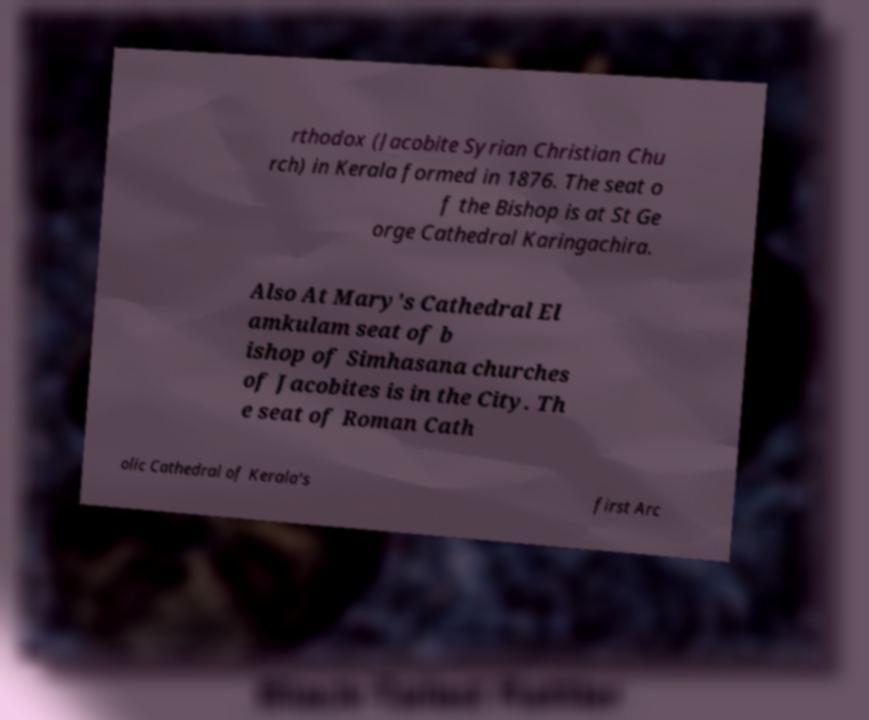What messages or text are displayed in this image? I need them in a readable, typed format. rthodox (Jacobite Syrian Christian Chu rch) in Kerala formed in 1876. The seat o f the Bishop is at St Ge orge Cathedral Karingachira. Also At Mary's Cathedral El amkulam seat of b ishop of Simhasana churches of Jacobites is in the City. Th e seat of Roman Cath olic Cathedral of Kerala's first Arc 